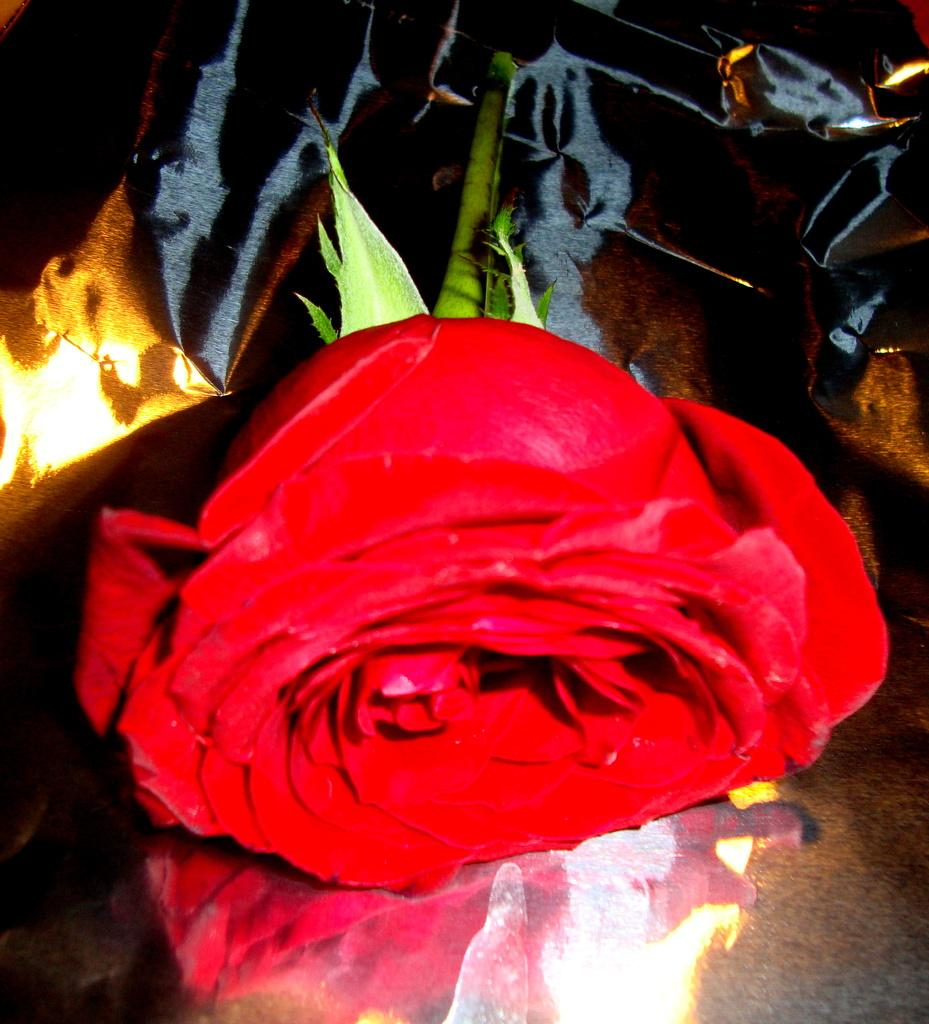What type of flower is in the image? There is a red flower in the image. Where is the red flower located? The red flower is on a surface. Reasoning: Let's think step by step by step in order to produce the conversation. We start by identifying the main subject in the image, which is the red flower. Then, we expand the conversation to include the location of the flower, which is on a surface. Each question is designed to elicit a specific detail about the image that is known from the provided facts. Absurd Question/Answer: Are there any animals from the zoo present in the image? No, there are no animals from the zoo present in the image. How many passengers are visible in the image? There are no passengers visible in the image, as it only features a red flower on a surface. Is there a pin holding the red flower in place in the image? No, there is no pin visible in the image, and the red flower is simply resting on a surface. 